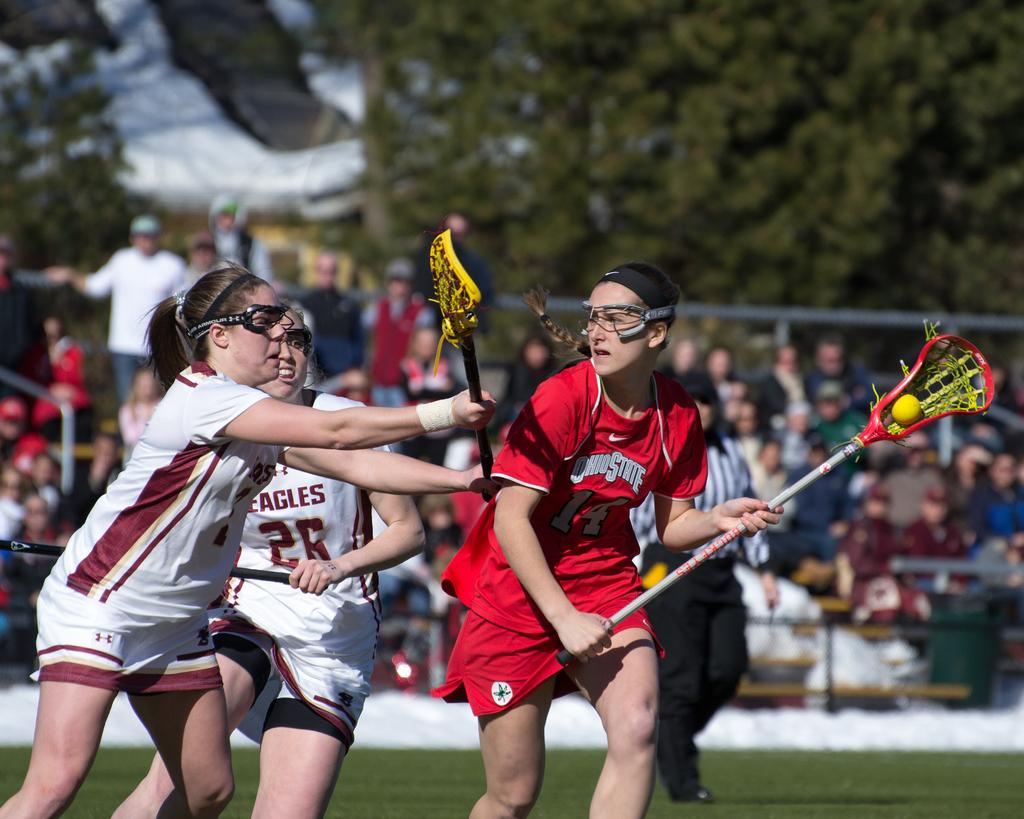<image>
Provide a brief description of the given image. lacross players from ohio state in red uniforms 